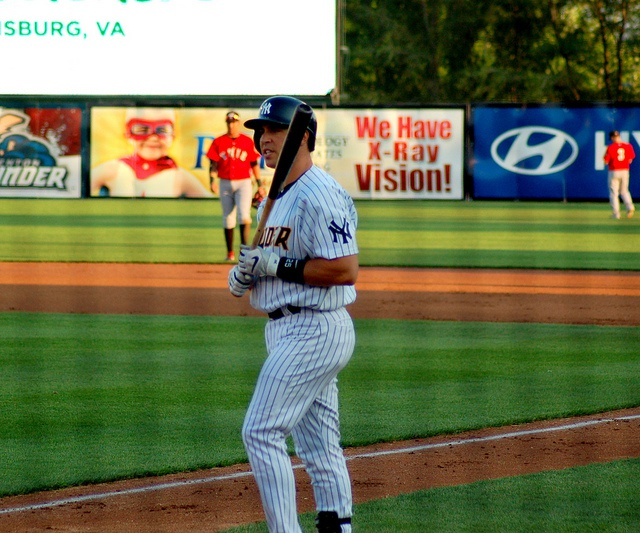Describe the objects in this image and their specific colors. I can see people in cyan, gray, lightblue, darkgray, and black tones, people in cyan, red, tan, orange, and gray tones, people in cyan, red, and tan tones, baseball bat in cyan, black, maroon, and gray tones, and baseball glove in cyan, gray, darkgray, and black tones in this image. 